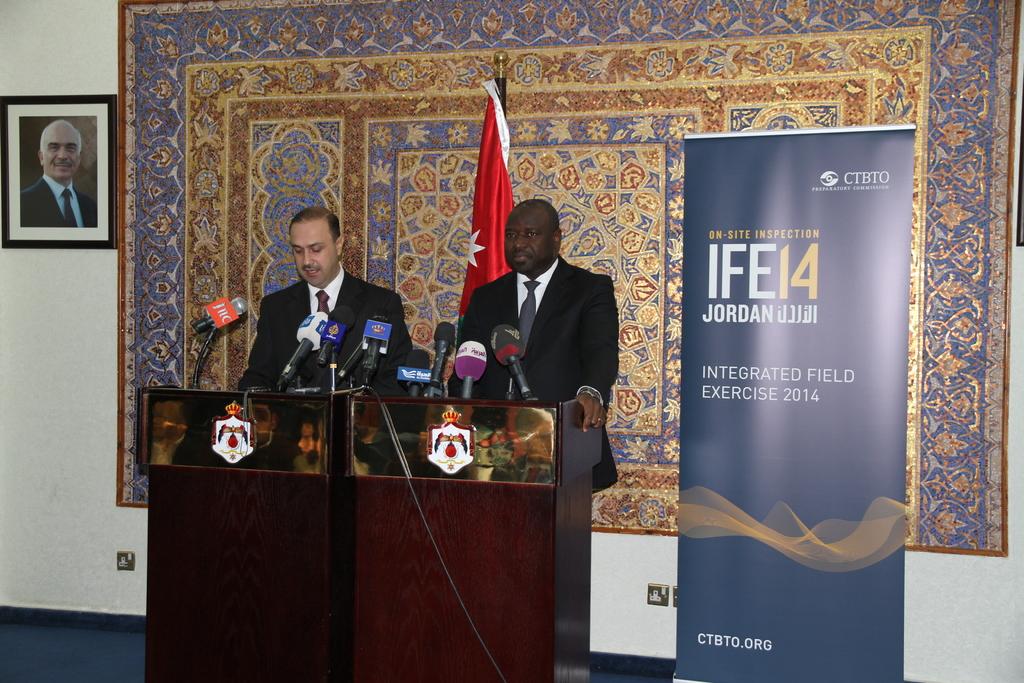What year was this meeting being held?
Ensure brevity in your answer.  2014. 